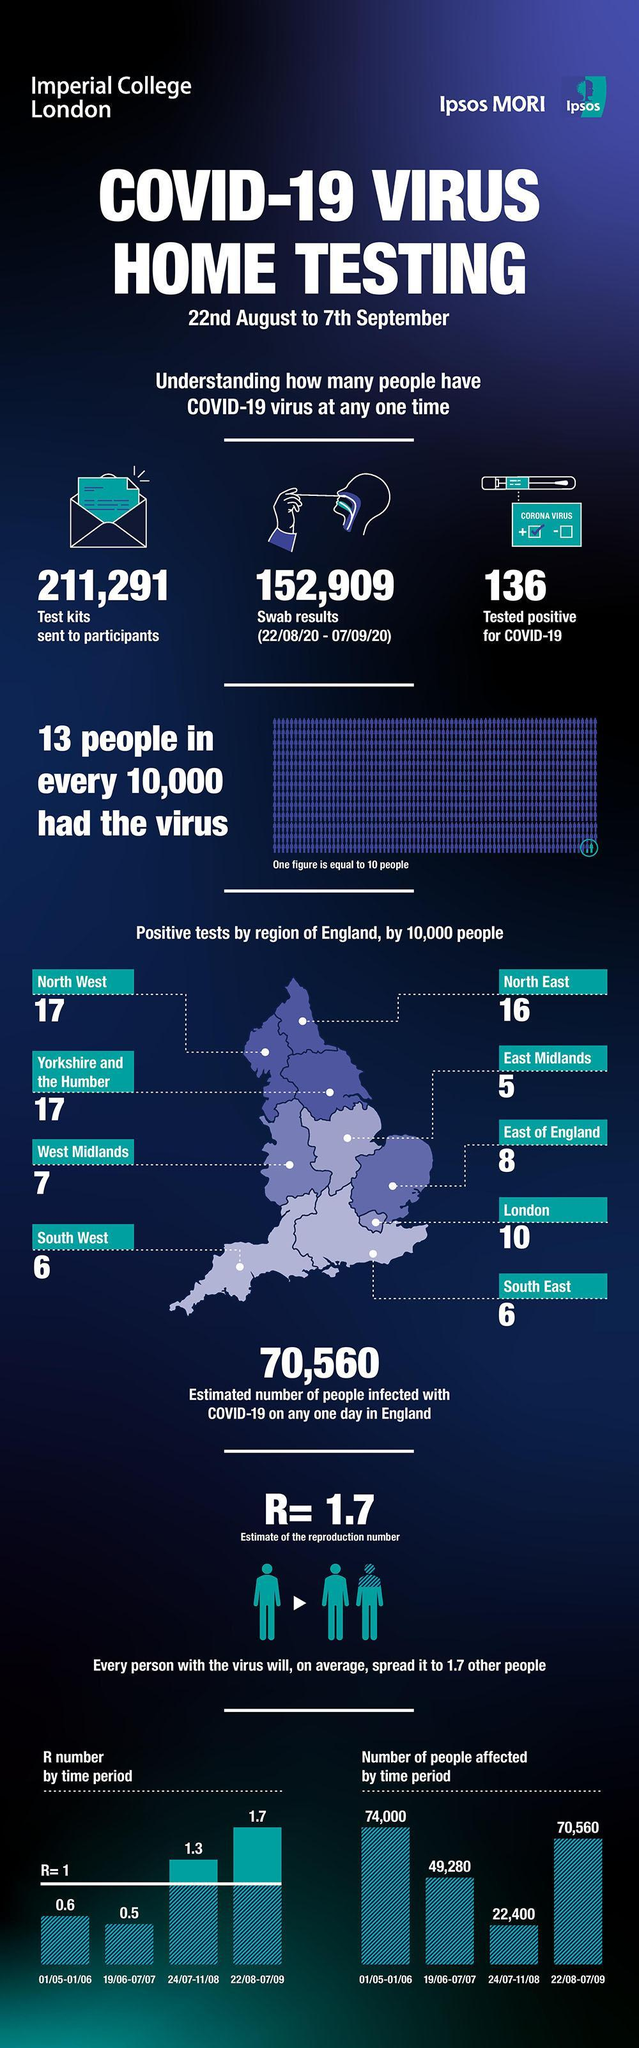How many people were affected between July 24th and August 11th?
Answer the question with a short phrase. 22,400 Besides North West, which other region in England has 17 positive tests? Yorkshire and the Humber Which region of England has 5 positive cases ? East Midlands How many tested positive ? 136 How many positive tests in South West? 6 How many swab results between 22 Aug and 7 Sep? 152,909 How many home testing kits were sent to participants? 211,291 How many positive tests in North West and North East combined? 33 Which region of England has 10 positive tests as per the graphic? London In which region of England were positive tests higher - North East or North West? North West 